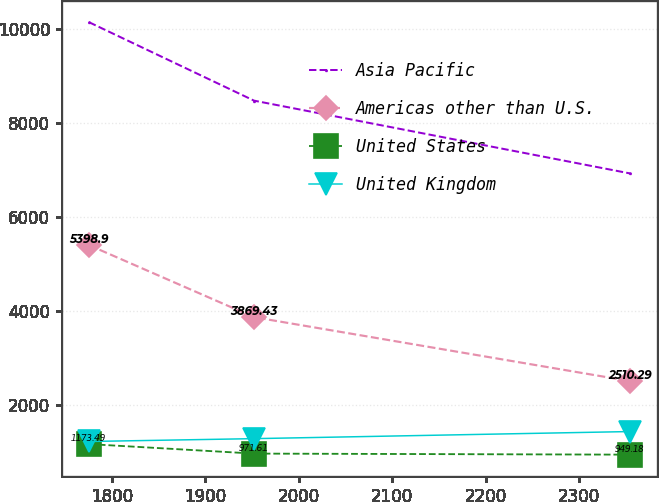Convert chart. <chart><loc_0><loc_0><loc_500><loc_500><line_chart><ecel><fcel>Asia Pacific<fcel>Americas other than U.S.<fcel>United States<fcel>United Kingdom<nl><fcel>1775.66<fcel>10135<fcel>5398.9<fcel>1173.49<fcel>1228.85<nl><fcel>1952.21<fcel>8469.01<fcel>3869.43<fcel>971.61<fcel>1289.19<nl><fcel>2354.7<fcel>6922.03<fcel>2510.29<fcel>949.18<fcel>1440.01<nl></chart> 